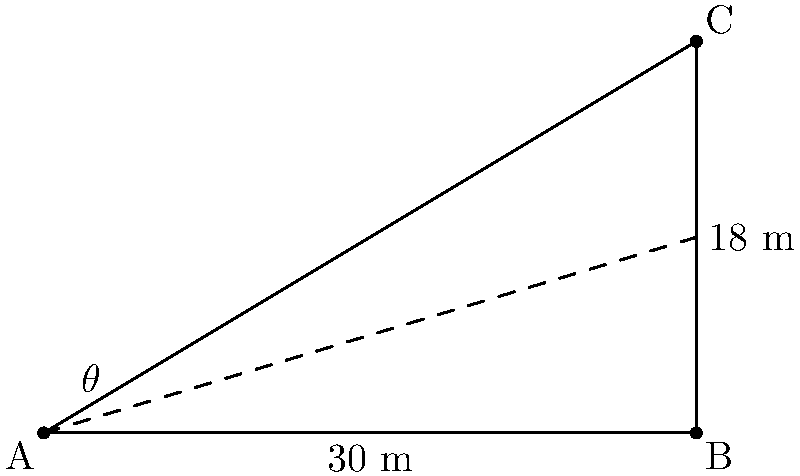In "Hammer's Grappling Hook Gambit," Hammer needs to scale a wall using his trusty grappling hook. The wall is 18 meters high, and Hammer is standing 30 meters away from its base. At what angle $\theta$ should Hammer throw his grappling hook to just reach the top of the wall with minimal effort? Let's approach this step-by-step:

1) We can model this situation as a right triangle, where:
   - The base of the triangle is 30 meters (distance from Hammer to the wall)
   - The height of the triangle is 18 meters (height of the wall)
   - The hypotenuse represents the path of the grappling hook
   - The angle $\theta$ is what we need to find

2) We can use the tangent function to find this angle:

   $\tan(\theta) = \frac{\text{opposite}}{\text{adjacent}} = \frac{\text{height}}{\text{distance}}$

3) Substituting our values:

   $\tan(\theta) = \frac{18}{30} = 0.6$

4) To find $\theta$, we need to use the inverse tangent (arctangent) function:

   $\theta = \tan^{-1}(0.6)$

5) Using a calculator or trigonometric tables:

   $\theta \approx 30.96^\circ$

6) Rounding to the nearest degree:

   $\theta \approx 31^\circ$

This angle will allow Hammer to reach the top of the wall with minimal effort, as it provides the shortest path for the grappling hook.
Answer: $31^\circ$ 